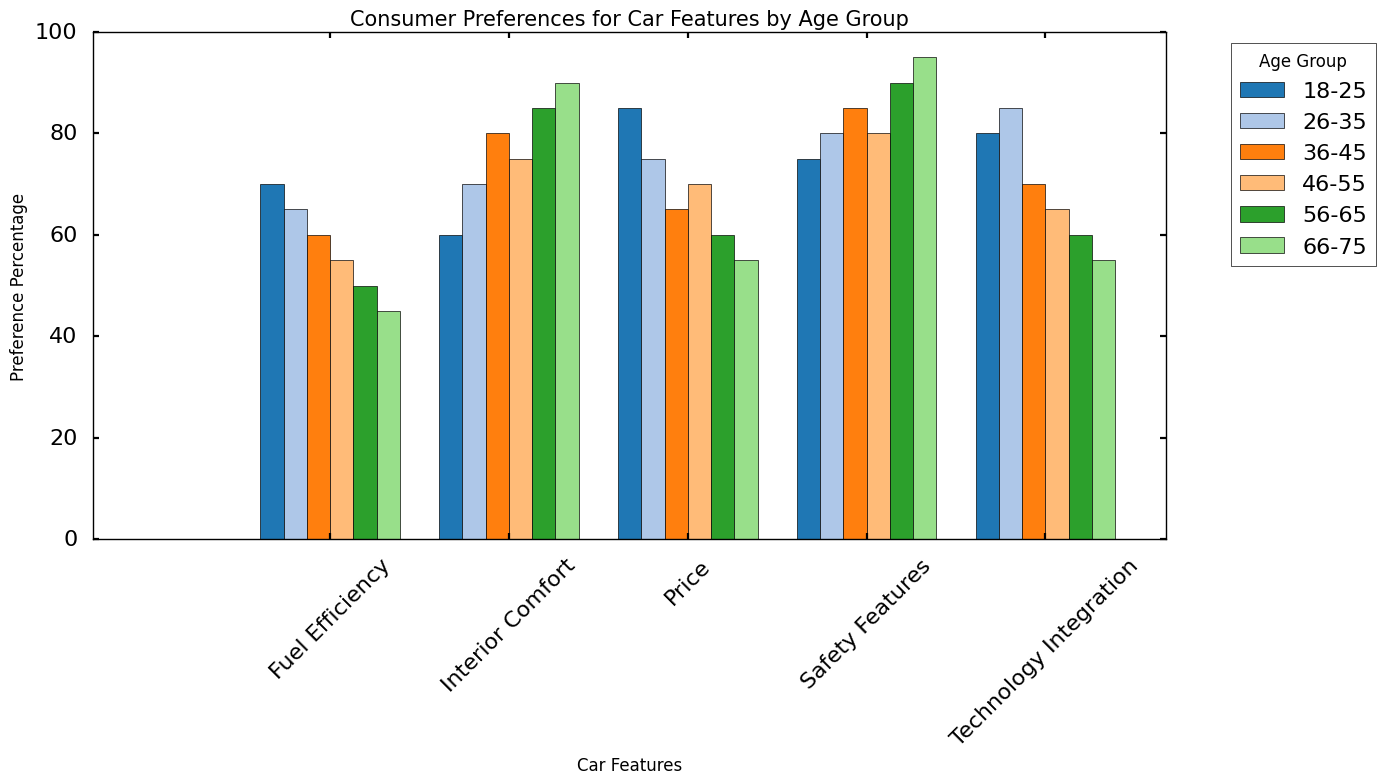Which age group has the highest preference percentage for Interior Comfort? Look at the bar heights for the "Interior Comfort" feature across all age groups. The tallest bar represents the age group with the highest preference percentage.
Answer: 66-75 How does the preference for Technology Integration compare between the 18-25 and 26-35 age groups? Compare the bar heights for "Technology Integration" for the 18-25 and 26-35 age groups. The bar for 26-35 is slightly taller than the bar for 18-25.
Answer: 26-35 has a higher preference Which car feature has the lowest preference percentage among the 56-65 age group? Look at the bars for the 56-65 age group and identify the shortest one, which represents the lowest preference percentage.
Answer: Technology Integration What is the average preference percentage for Safety Features across all age groups? Sum up the preference percentages for "Safety Features" across all age groups (75, 80, 85, 80, 90, 95) and then divide by the number of age groups, which is 6.
Answer: 84.2 18-25: 70 - 85
Answer: = 15 26-35: 65 - 75
Answer: = 10 36-45: 60 - 65
Answer: = 5 46-55: 55 - 70
Answer: = 15 56-65: 50 - 60
Answer: = 10 66-75: 45 - 55
Answer: = 10 How does the preference for Fuel Efficiency change across the entire age spectrum from 18-25 to 66-75? Observe the heights of the bars for "Fuel Efficiency" from age group 18-25 to 66-75, noting the trend. The heights decrease steadily as the age increases from the highest 70 to the lowest 45.
Answer: It decreases steadily What is the combined preference percentage for Price and Technology Integration for the 56-65 age group? Add the preference percentages for "Price" (60) and "Technology Integration" (60) for the 56-65 age group.
Answer: 120 